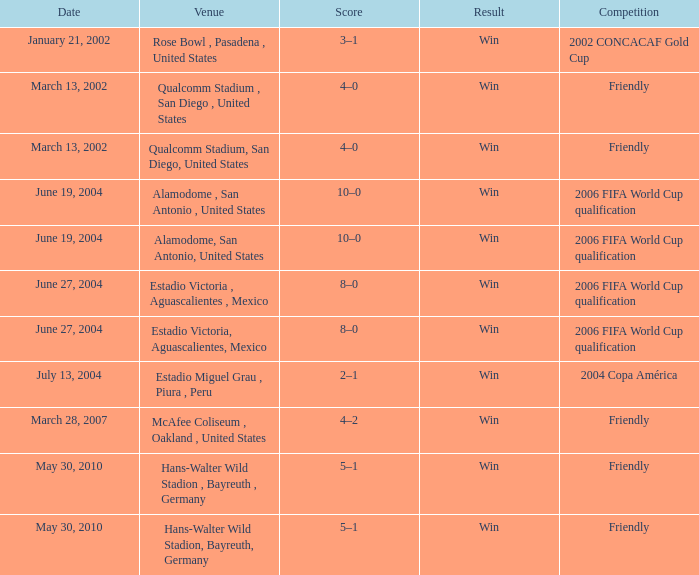On which date did the 2006 fifa world cup qualification take place at alamodome, san antonio, united states? June 19, 2004, June 19, 2004. 